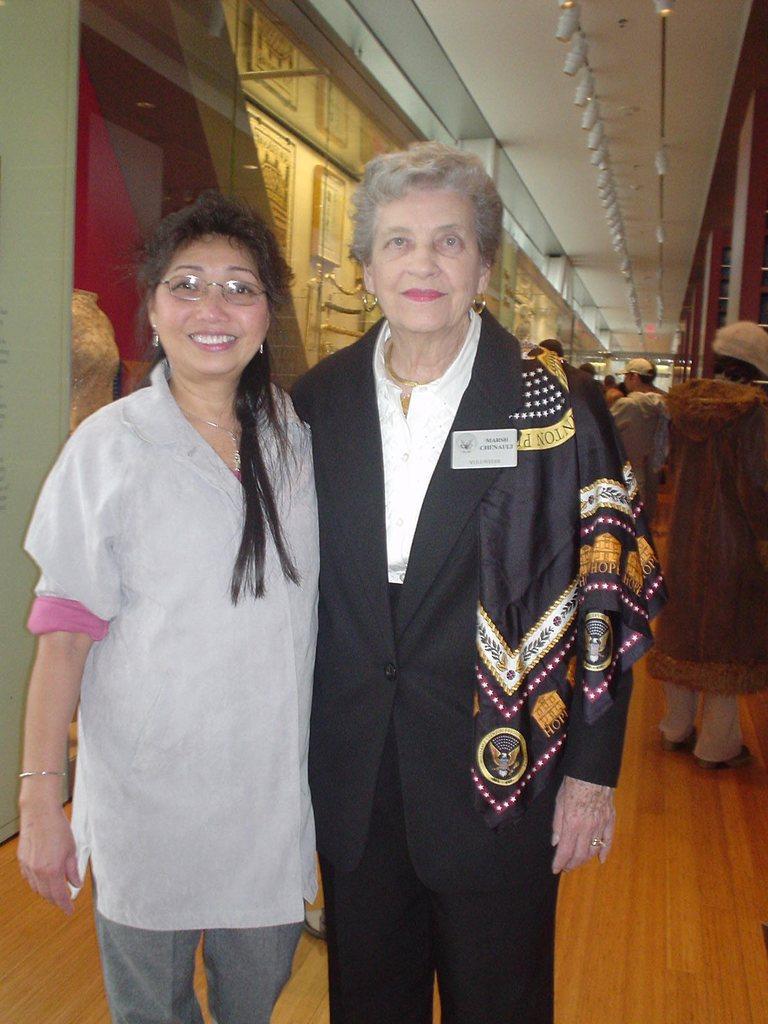In one or two sentences, can you explain what this image depicts? In this picture we can see two people and they are smiling and in the background we can see people, floor, roof and some objects. 